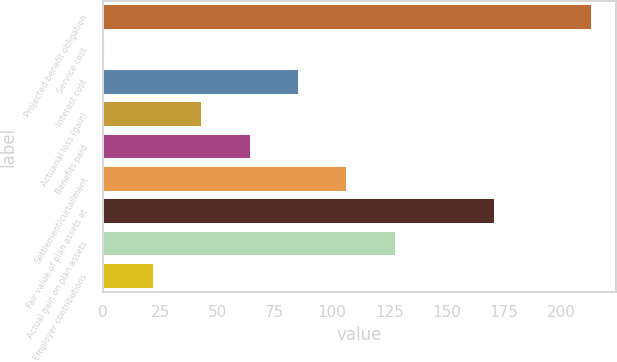Convert chart to OTSL. <chart><loc_0><loc_0><loc_500><loc_500><bar_chart><fcel>Projected benefit obligation<fcel>Service cost<fcel>Interest cost<fcel>Actuarial loss (gain)<fcel>Benefits paid<fcel>Settlement/curtailment<fcel>Fair value of plan assets at<fcel>Actual gain on plan assets<fcel>Employer contributions<nl><fcel>213.38<fcel>1.2<fcel>85.56<fcel>43.38<fcel>64.47<fcel>106.65<fcel>171.2<fcel>127.74<fcel>22.29<nl></chart> 